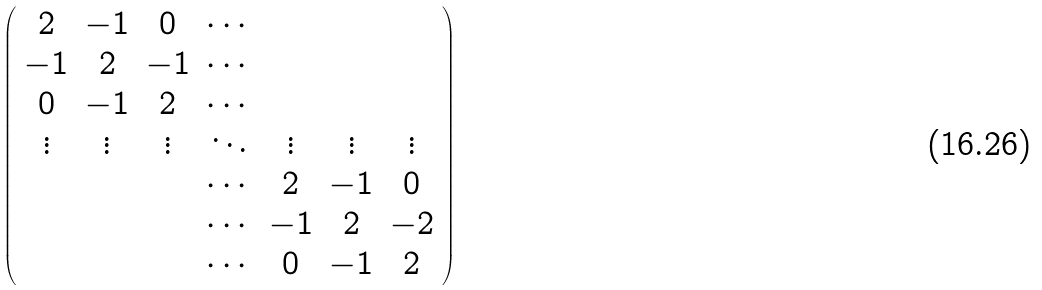<formula> <loc_0><loc_0><loc_500><loc_500>\left ( \begin{array} { c c c c c c c } 2 & - 1 & 0 & \cdots & & & \\ - 1 & 2 & - 1 & \cdots & & & \\ 0 & - 1 & 2 & \cdots & & & \\ \vdots & \vdots & \vdots & \ddots & \vdots & \vdots & \vdots \\ & & & \cdots & 2 & - 1 & 0 \\ & & & \cdots & - 1 & 2 & - 2 \\ & & & \cdots & 0 & - 1 & 2 \end{array} \right )</formula> 